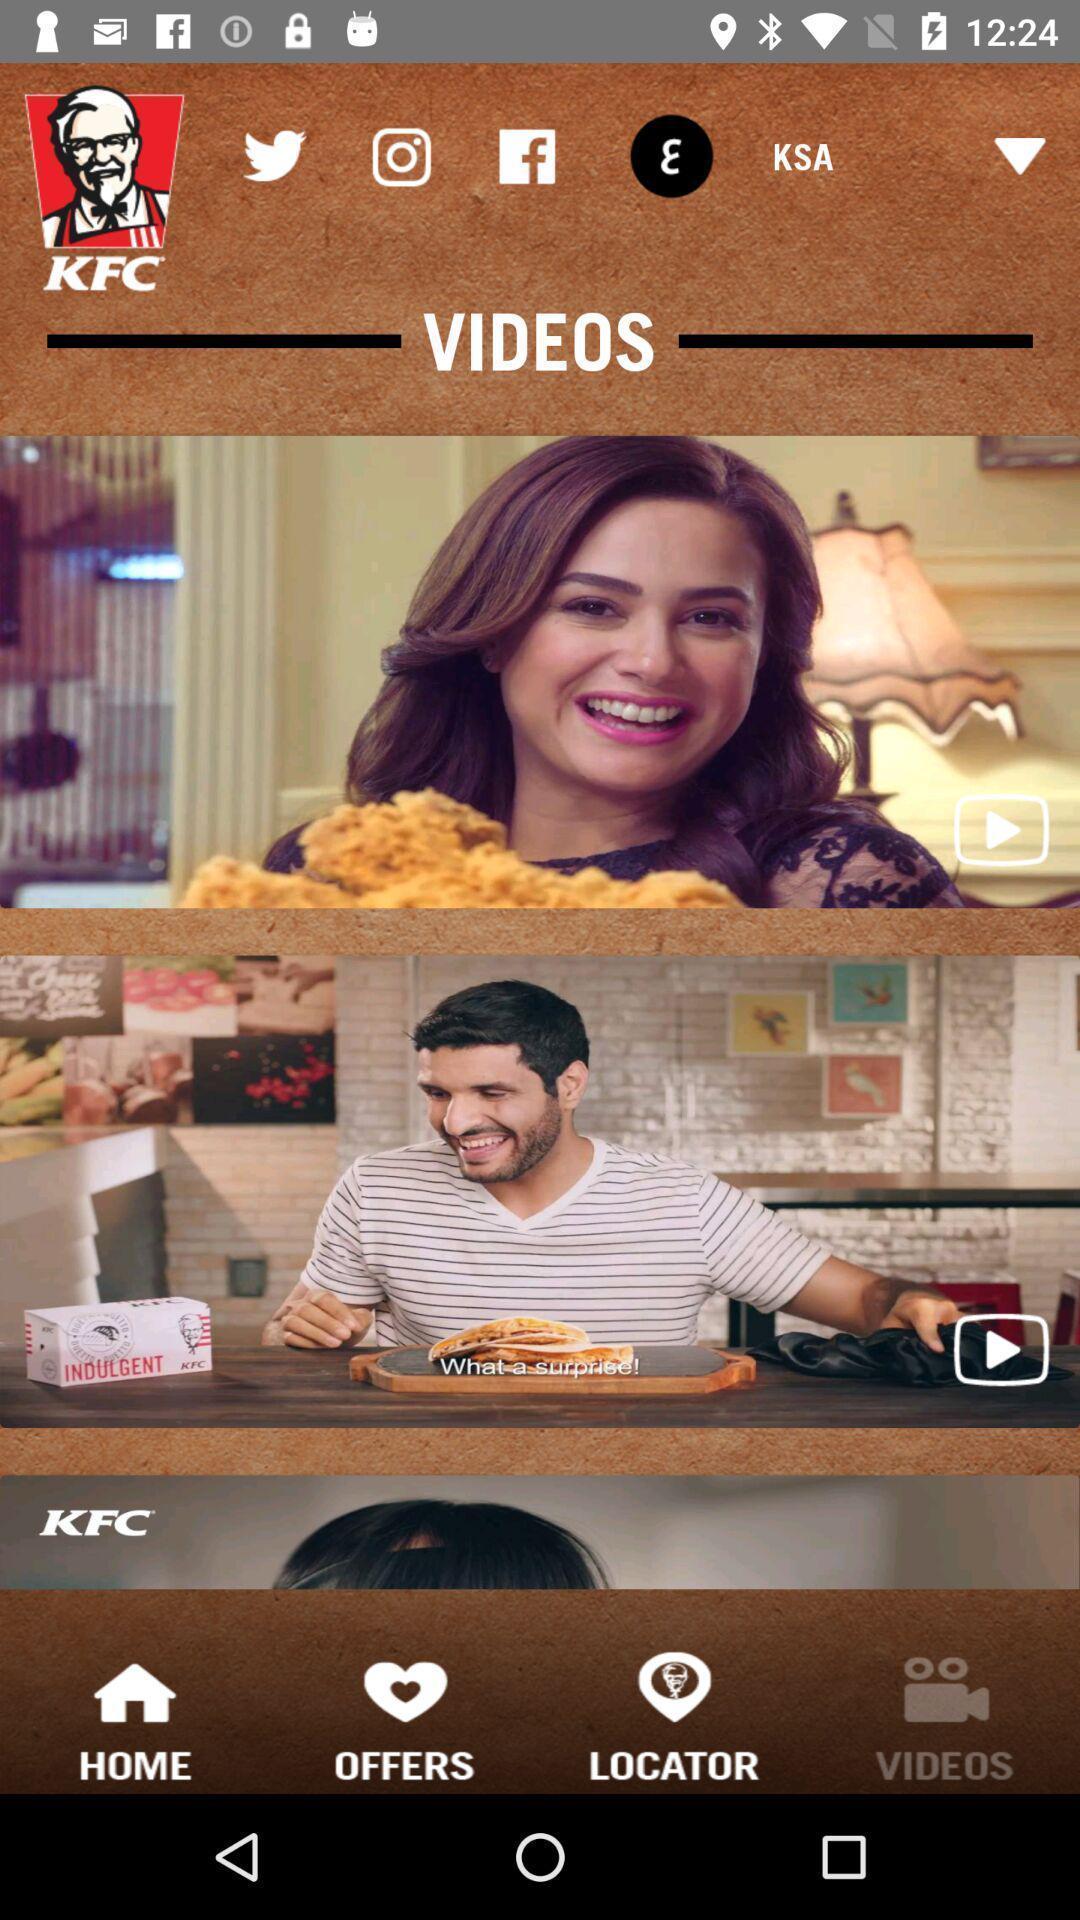Tell me about the visual elements in this screen capture. Page showing videos from a restaurant app. 